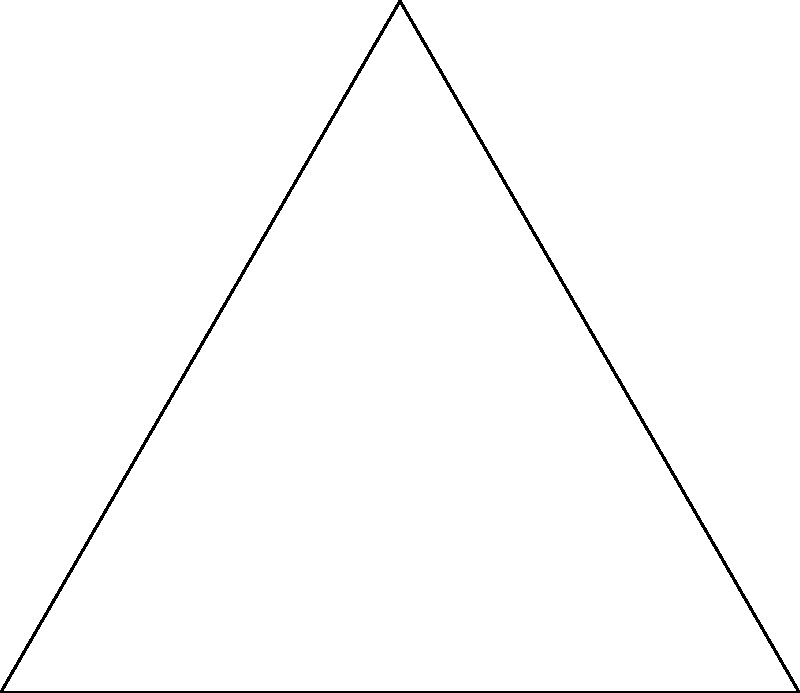In the diagram, a simplified representation of a Mongolian script character is inscribed within a circle, which is itself inscribed in an equilateral triangle ABC. If the side length of the triangle is 2 units, what is the radius of the inscribed circle? Let's approach this step-by-step:

1) In an equilateral triangle, the radius of the inscribed circle is given by the formula:

   $$r = \frac{a}{2\sqrt{3}}$$

   where $a$ is the side length of the triangle.

2) We're given that the side length of the triangle is 2 units. Let's substitute this into our formula:

   $$r = \frac{2}{2\sqrt{3}} = \frac{1}{\sqrt{3}}$$

3) To simplify this, we can rationalize the denominator:

   $$r = \frac{1}{\sqrt{3}} \cdot \frac{\sqrt{3}}{\sqrt{3}} = \frac{\sqrt{3}}{3}$$

4) This can be expressed as a decimal:

   $$r \approx 0.577$$

Thus, the radius of the circle inscribing the Mongolian script character is $\frac{\sqrt{3}}{3}$ units or approximately 0.577 units.
Answer: $\frac{\sqrt{3}}{3}$ units 